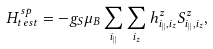Convert formula to latex. <formula><loc_0><loc_0><loc_500><loc_500>H ^ { s p } _ { t e s t } = - g _ { S } \mu _ { B } \sum _ { i _ { | | } } \sum _ { i _ { z } } h ^ { z } _ { i _ { | | } , i _ { z } } S ^ { z } _ { i _ { | | } , i _ { z } } ,</formula> 